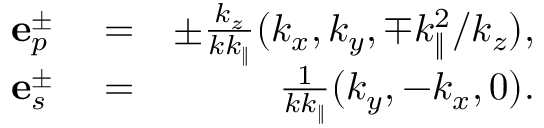<formula> <loc_0><loc_0><loc_500><loc_500>\begin{array} { r l r } { e _ { p } ^ { \pm } } & = } & { \pm \frac { k _ { z } } { k k _ { \| } } ( k _ { x } , k _ { y } , \mp k _ { \| } ^ { 2 } / k _ { z } ) , } \\ { e _ { s } ^ { \pm } } & = } & { \frac { 1 } { k k _ { \| } } ( k _ { y } , - k _ { x } , 0 ) . } \end{array}</formula> 